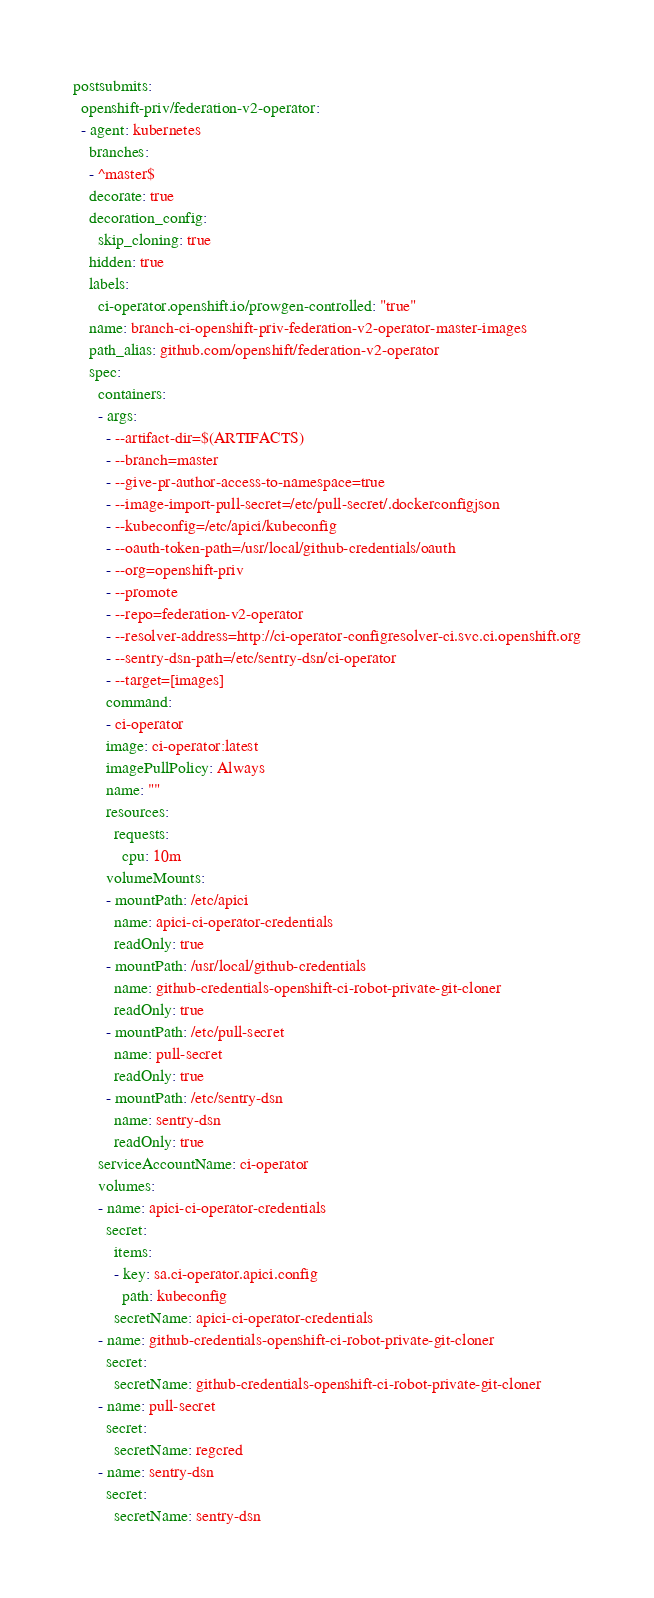<code> <loc_0><loc_0><loc_500><loc_500><_YAML_>postsubmits:
  openshift-priv/federation-v2-operator:
  - agent: kubernetes
    branches:
    - ^master$
    decorate: true
    decoration_config:
      skip_cloning: true
    hidden: true
    labels:
      ci-operator.openshift.io/prowgen-controlled: "true"
    name: branch-ci-openshift-priv-federation-v2-operator-master-images
    path_alias: github.com/openshift/federation-v2-operator
    spec:
      containers:
      - args:
        - --artifact-dir=$(ARTIFACTS)
        - --branch=master
        - --give-pr-author-access-to-namespace=true
        - --image-import-pull-secret=/etc/pull-secret/.dockerconfigjson
        - --kubeconfig=/etc/apici/kubeconfig
        - --oauth-token-path=/usr/local/github-credentials/oauth
        - --org=openshift-priv
        - --promote
        - --repo=federation-v2-operator
        - --resolver-address=http://ci-operator-configresolver-ci.svc.ci.openshift.org
        - --sentry-dsn-path=/etc/sentry-dsn/ci-operator
        - --target=[images]
        command:
        - ci-operator
        image: ci-operator:latest
        imagePullPolicy: Always
        name: ""
        resources:
          requests:
            cpu: 10m
        volumeMounts:
        - mountPath: /etc/apici
          name: apici-ci-operator-credentials
          readOnly: true
        - mountPath: /usr/local/github-credentials
          name: github-credentials-openshift-ci-robot-private-git-cloner
          readOnly: true
        - mountPath: /etc/pull-secret
          name: pull-secret
          readOnly: true
        - mountPath: /etc/sentry-dsn
          name: sentry-dsn
          readOnly: true
      serviceAccountName: ci-operator
      volumes:
      - name: apici-ci-operator-credentials
        secret:
          items:
          - key: sa.ci-operator.apici.config
            path: kubeconfig
          secretName: apici-ci-operator-credentials
      - name: github-credentials-openshift-ci-robot-private-git-cloner
        secret:
          secretName: github-credentials-openshift-ci-robot-private-git-cloner
      - name: pull-secret
        secret:
          secretName: regcred
      - name: sentry-dsn
        secret:
          secretName: sentry-dsn
</code> 